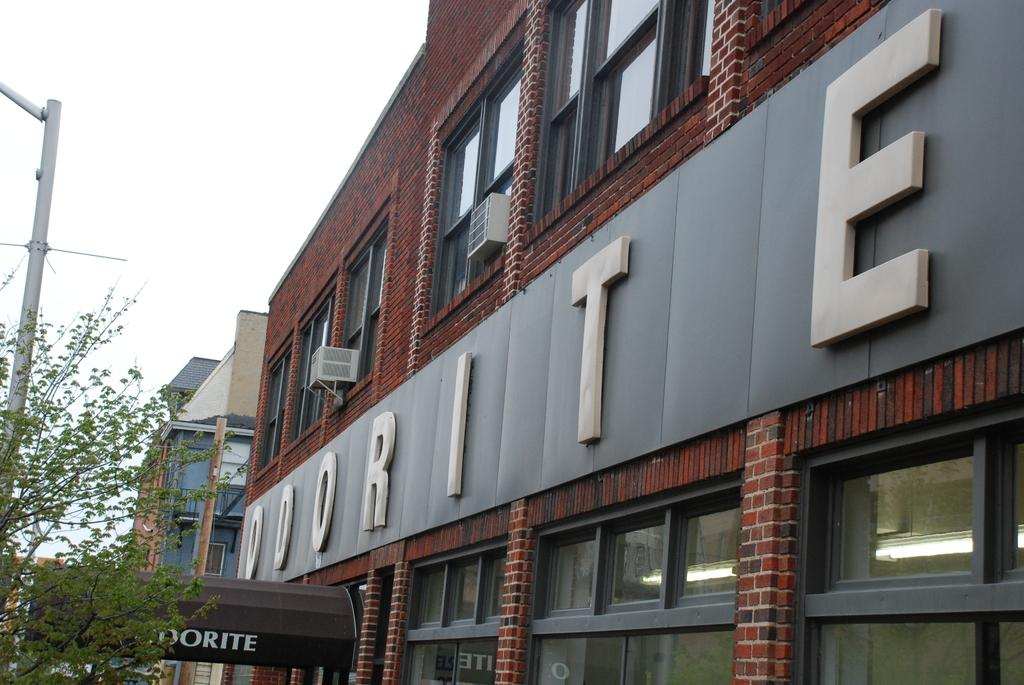What type of natural element can be seen in the image? There is a tree in the image. What man-made structure is present in the image? There is a light pole in the image. What type of buildings are visible in the image? There are buildings in the image. What object can be seen with writing or information on it? There is a board in the image. What architectural feature can be seen on the buildings? There are windows in the image. What part of the natural environment is visible in the image? The sky is visible in the image. Based on the presence of the sky and the absence of artificial light, can we infer the time of day the image was taken? Yes, the image was likely taken during the day. How many nuts are hanging from the tree in the image? There are no nuts visible on the tree in the image. Can you describe the type of flowers growing near the light pole? There are no flowers present in the image. 